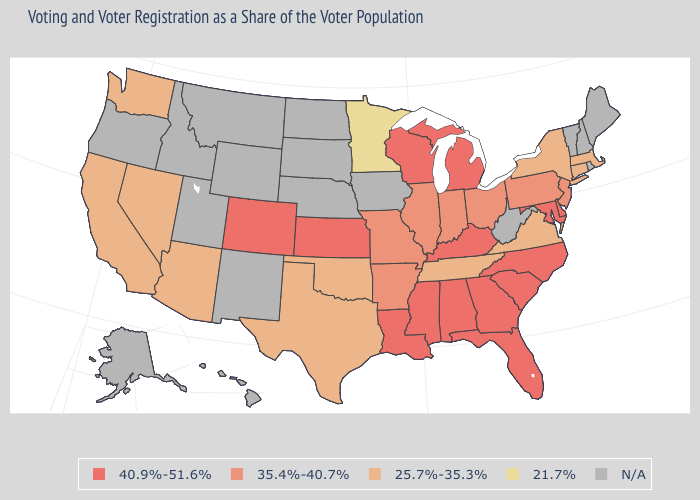What is the lowest value in the MidWest?
Write a very short answer. 21.7%. How many symbols are there in the legend?
Keep it brief. 5. What is the value of Mississippi?
Short answer required. 40.9%-51.6%. Name the states that have a value in the range 35.4%-40.7%?
Quick response, please. Arkansas, Illinois, Indiana, Missouri, New Jersey, Ohio, Pennsylvania. What is the value of Rhode Island?
Answer briefly. N/A. What is the lowest value in the West?
Quick response, please. 25.7%-35.3%. Which states have the lowest value in the Northeast?
Answer briefly. Connecticut, Massachusetts, New York. What is the highest value in states that border Nebraska?
Keep it brief. 40.9%-51.6%. What is the value of New Mexico?
Give a very brief answer. N/A. What is the lowest value in states that border Connecticut?
Give a very brief answer. 25.7%-35.3%. What is the highest value in the Northeast ?
Be succinct. 35.4%-40.7%. What is the value of Kentucky?
Give a very brief answer. 40.9%-51.6%. Name the states that have a value in the range 40.9%-51.6%?
Short answer required. Alabama, Colorado, Delaware, Florida, Georgia, Kansas, Kentucky, Louisiana, Maryland, Michigan, Mississippi, North Carolina, South Carolina, Wisconsin. Name the states that have a value in the range 21.7%?
Answer briefly. Minnesota. 